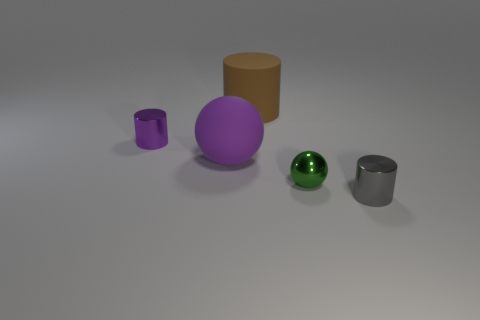There is a large rubber thing in front of the small cylinder behind the tiny gray thing; what color is it?
Offer a terse response. Purple. What number of things are either small cylinders that are in front of the small purple object or small gray cylinders in front of the matte ball?
Your answer should be compact. 1. What color is the small shiny ball?
Provide a short and direct response. Green. What number of brown cylinders have the same material as the large purple sphere?
Offer a very short reply. 1. Is the number of purple matte balls greater than the number of green metal blocks?
Ensure brevity in your answer.  Yes. How many brown cylinders are on the right side of the sphere on the left side of the green shiny ball?
Give a very brief answer. 1. How many things are small things behind the tiny gray object or tiny cyan balls?
Offer a very short reply. 2. Is there a big brown thing that has the same shape as the small gray metal thing?
Provide a short and direct response. Yes. There is a large object behind the metallic cylinder that is on the left side of the gray shiny object; what shape is it?
Provide a short and direct response. Cylinder. How many cylinders are either small cyan rubber objects or brown matte things?
Offer a very short reply. 1. 